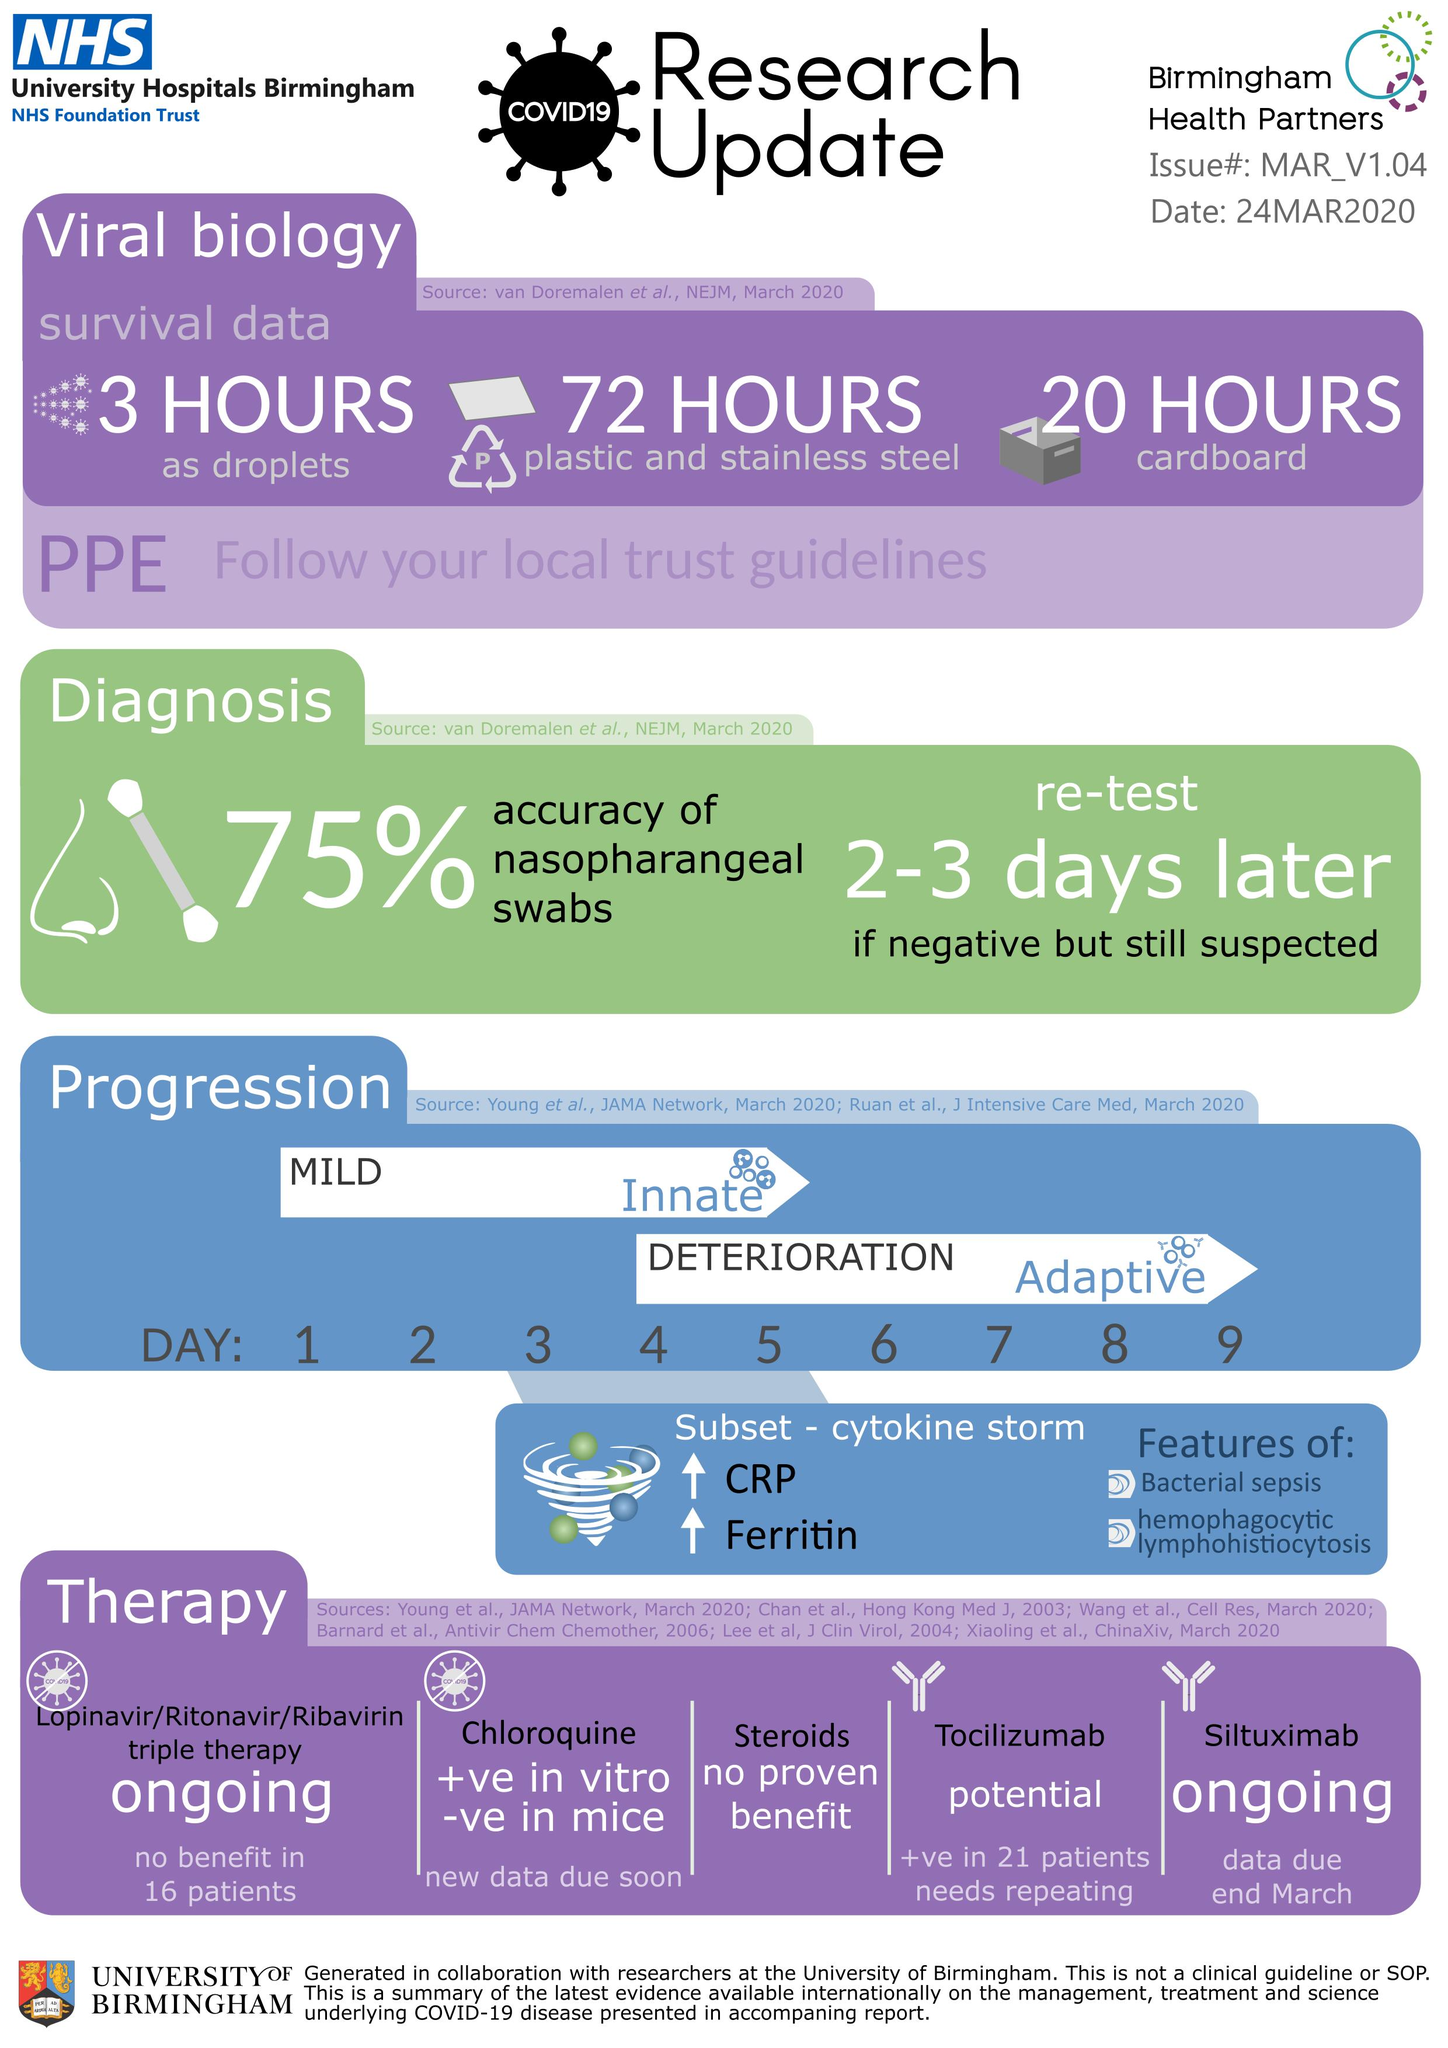Point out several critical features in this image. The COVID-19 virus can remain on plastic and stainless steel surfaces for up to 72 hours, according to recent studies. According to the available data, the accuracy percentage of nasopharyngeal swabs taken for the diagnosis of Covid-19 is 75%. The COVID-19 virus can remain on cardboard for up to 20 hours, The COVID-19 virus can remain as droplets in the air for up to three hours. 